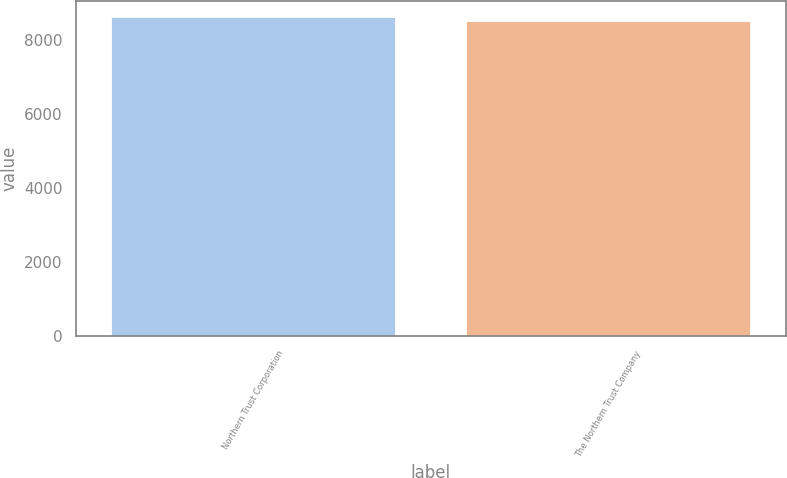Convert chart to OTSL. <chart><loc_0><loc_0><loc_500><loc_500><bar_chart><fcel>Northern Trust Corporation<fcel>The Northern Trust Company<nl><fcel>8626.3<fcel>8517.8<nl></chart> 